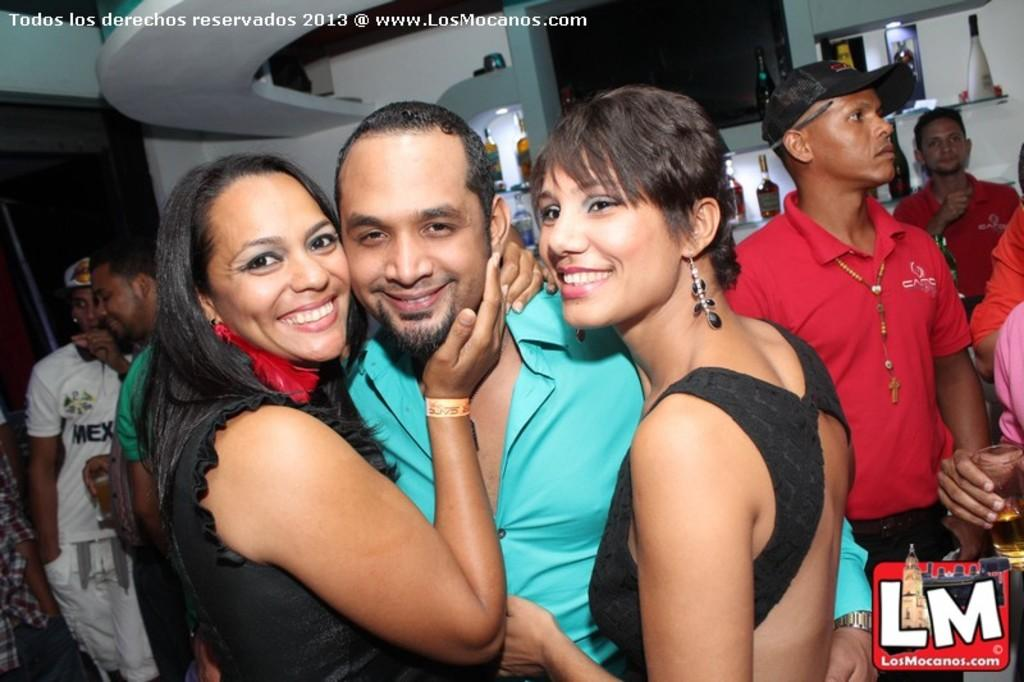Who or what is present in the image? There are people in the image. What can be seen illuminated in the image? There are lights visible in the image. What type of containers are in the image? There are bottles in the image. What type of furniture is in the image? There are shelves in the image. Can you describe any other objects in the image? There are other unspecified objects in the image. What song is being sung by the people in the image? There is no indication in the image that the people are singing a song, so it cannot be determined from the picture. 